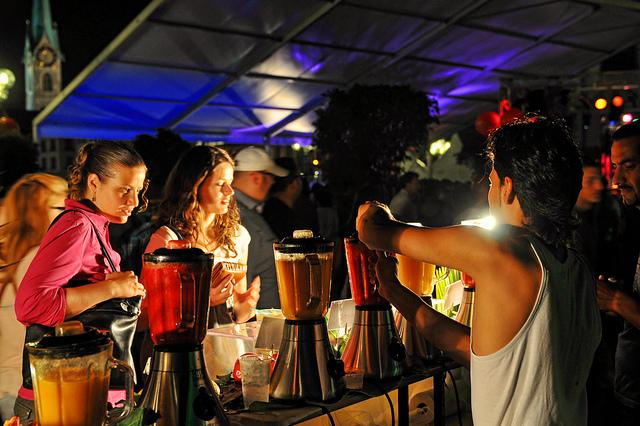What is the boy doing? blending 